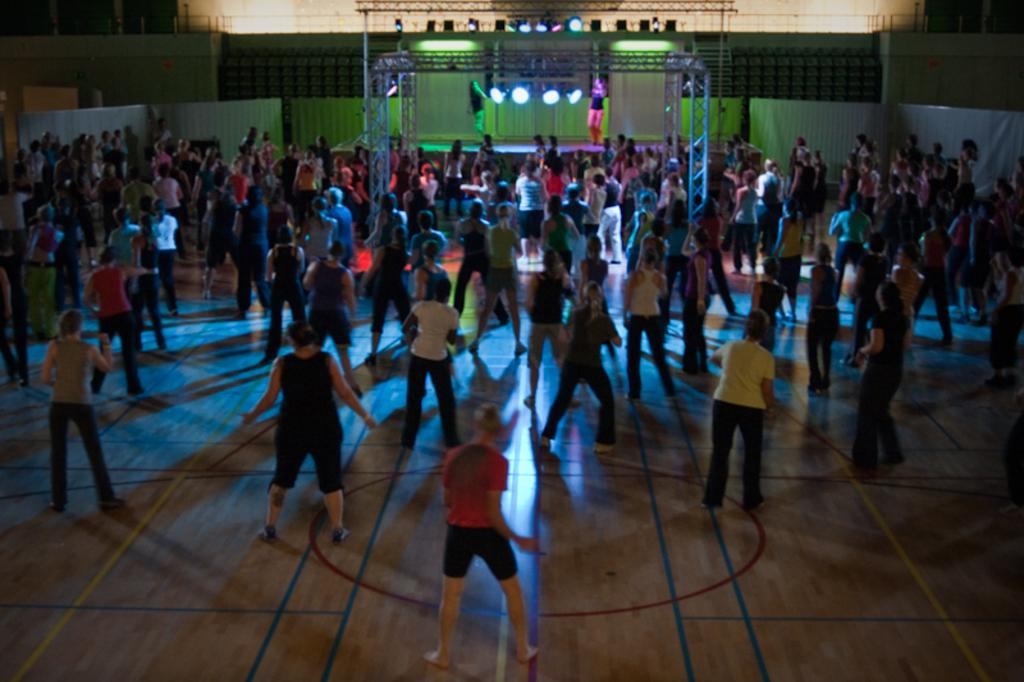What are the people in the image doing? There are people dancing in the image. What can be seen in the background of the image? There are focus lights and a stage in the background of the image. Can you describe the dancers on the stage? Two women are dancing on the stage. What type of chair is placed near the coast in the image? There is no chair or coast present in the image; it features people dancing with focus lights and a stage in the background. 